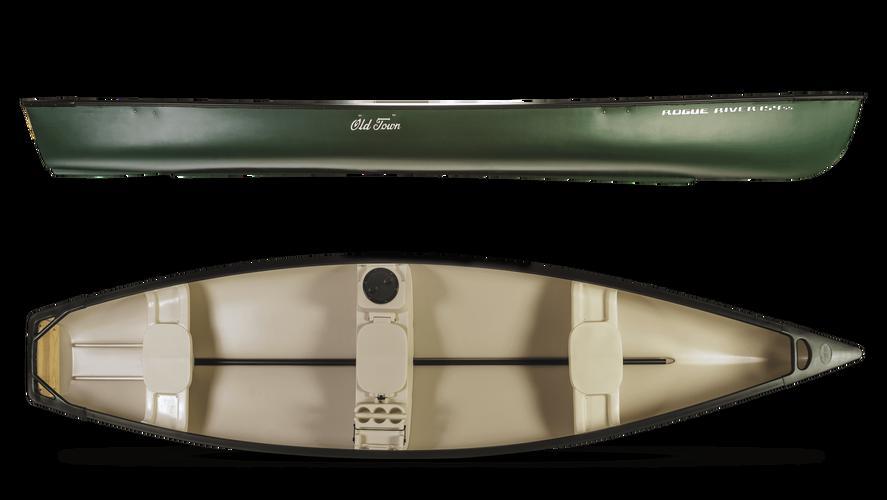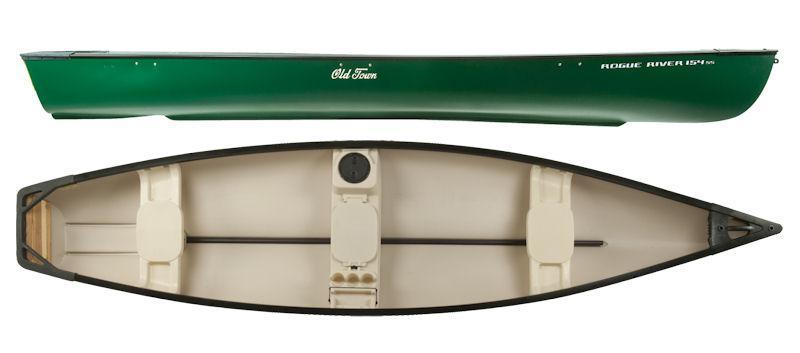The first image is the image on the left, the second image is the image on the right. Considering the images on both sides, is "At least one image shows a boat displayed horizontally in both side and aerial views." valid? Answer yes or no. Yes. The first image is the image on the left, the second image is the image on the right. Analyze the images presented: Is the assertion "Both images show top and side angles of a green boat." valid? Answer yes or no. Yes. 